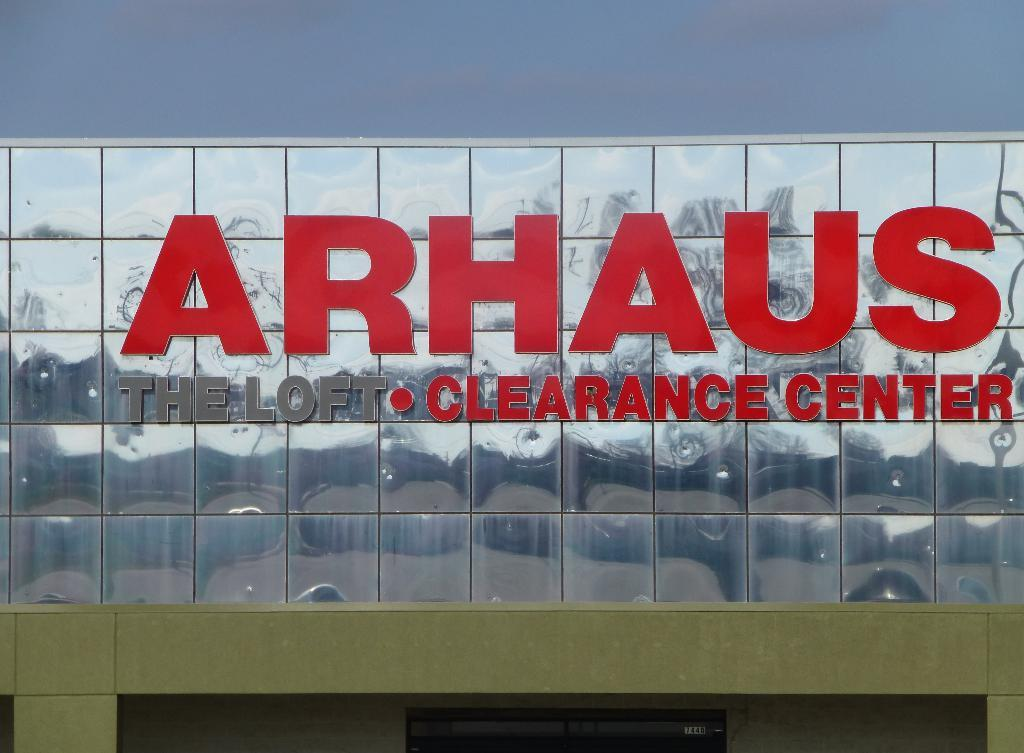<image>
Describe the image concisely. A sign for a store name Arhaus Clearance Center. 